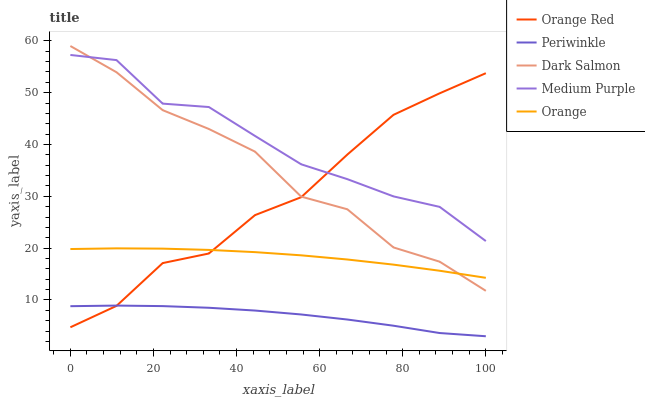Does Periwinkle have the minimum area under the curve?
Answer yes or no. Yes. Does Medium Purple have the maximum area under the curve?
Answer yes or no. Yes. Does Orange have the minimum area under the curve?
Answer yes or no. No. Does Orange have the maximum area under the curve?
Answer yes or no. No. Is Orange the smoothest?
Answer yes or no. Yes. Is Dark Salmon the roughest?
Answer yes or no. Yes. Is Periwinkle the smoothest?
Answer yes or no. No. Is Periwinkle the roughest?
Answer yes or no. No. Does Periwinkle have the lowest value?
Answer yes or no. Yes. Does Orange have the lowest value?
Answer yes or no. No. Does Dark Salmon have the highest value?
Answer yes or no. Yes. Does Orange have the highest value?
Answer yes or no. No. Is Periwinkle less than Orange?
Answer yes or no. Yes. Is Orange greater than Periwinkle?
Answer yes or no. Yes. Does Medium Purple intersect Orange Red?
Answer yes or no. Yes. Is Medium Purple less than Orange Red?
Answer yes or no. No. Is Medium Purple greater than Orange Red?
Answer yes or no. No. Does Periwinkle intersect Orange?
Answer yes or no. No. 